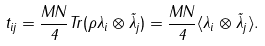<formula> <loc_0><loc_0><loc_500><loc_500>t _ { i j } = \frac { M N } { 4 } T r ( \rho \lambda _ { i } \otimes \tilde { \lambda } _ { j } ) = \frac { M N } { 4 } \langle \lambda _ { i } \otimes \tilde { \lambda } _ { j } \rangle .</formula> 